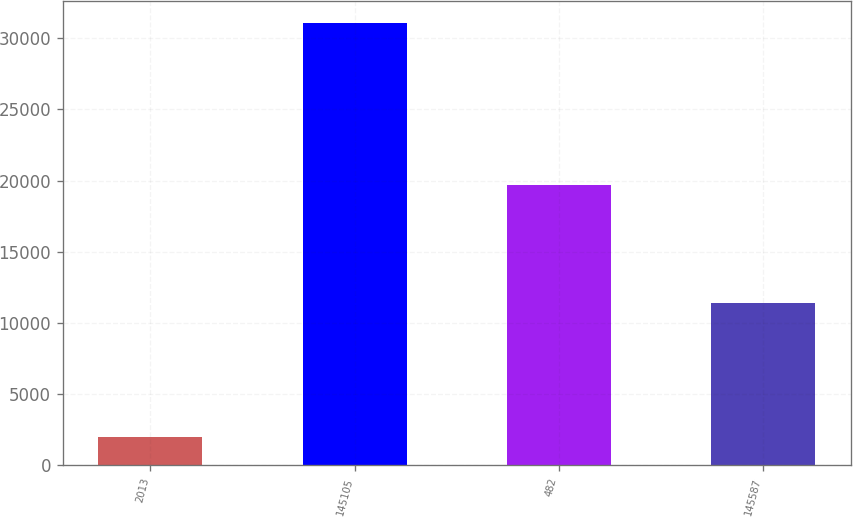Convert chart. <chart><loc_0><loc_0><loc_500><loc_500><bar_chart><fcel>2013<fcel>145105<fcel>482<fcel>145587<nl><fcel>2012<fcel>31087<fcel>19719<fcel>11368<nl></chart> 